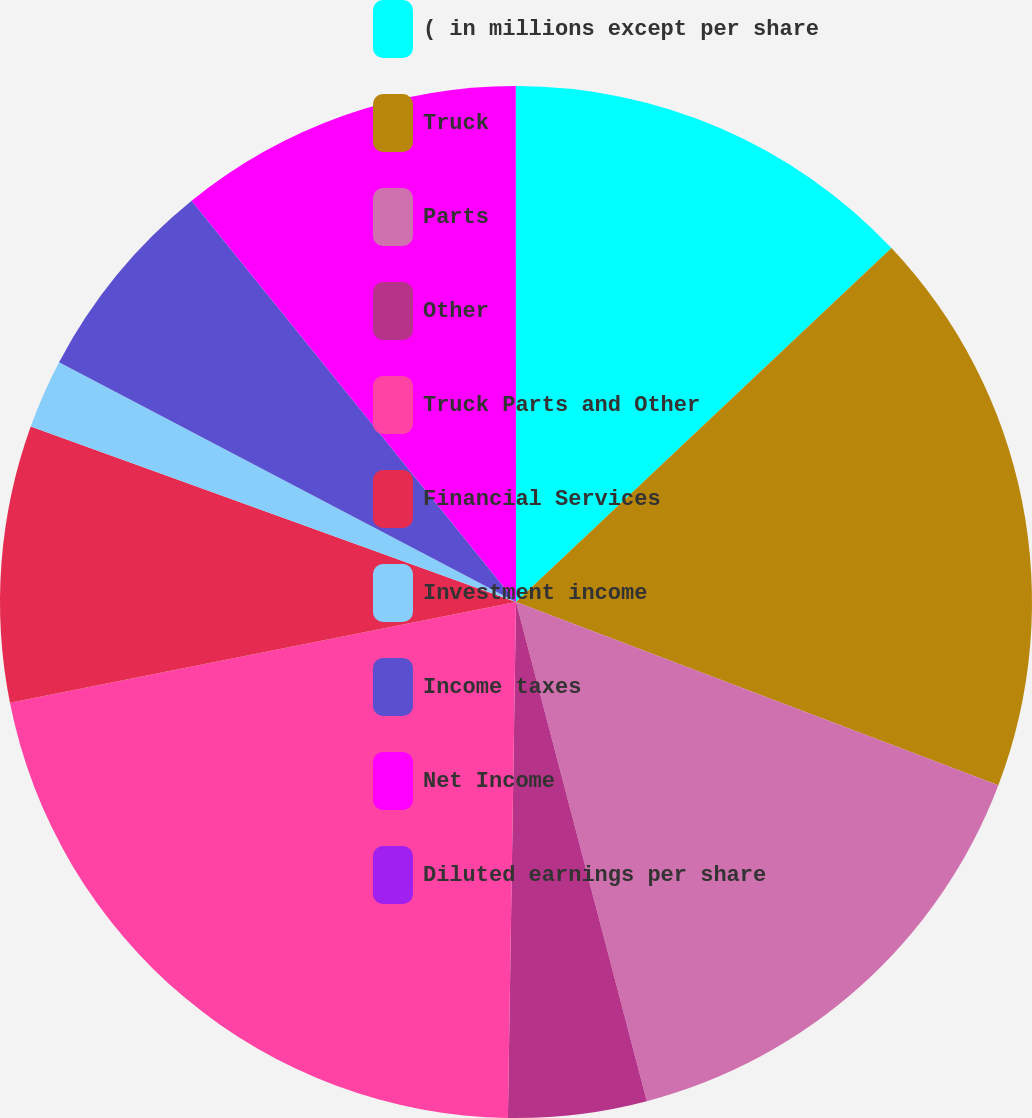<chart> <loc_0><loc_0><loc_500><loc_500><pie_chart><fcel>( in millions except per share<fcel>Truck<fcel>Parts<fcel>Other<fcel>Truck Parts and Other<fcel>Financial Services<fcel>Investment income<fcel>Income taxes<fcel>Net Income<fcel>Diluted earnings per share<nl><fcel>12.97%<fcel>17.81%<fcel>15.14%<fcel>4.33%<fcel>21.62%<fcel>8.65%<fcel>2.17%<fcel>6.49%<fcel>10.81%<fcel>0.01%<nl></chart> 